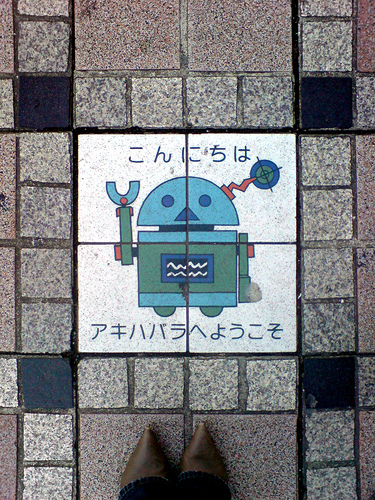<image>
Can you confirm if the robot is in the wall? Yes. The robot is contained within or inside the wall, showing a containment relationship. 